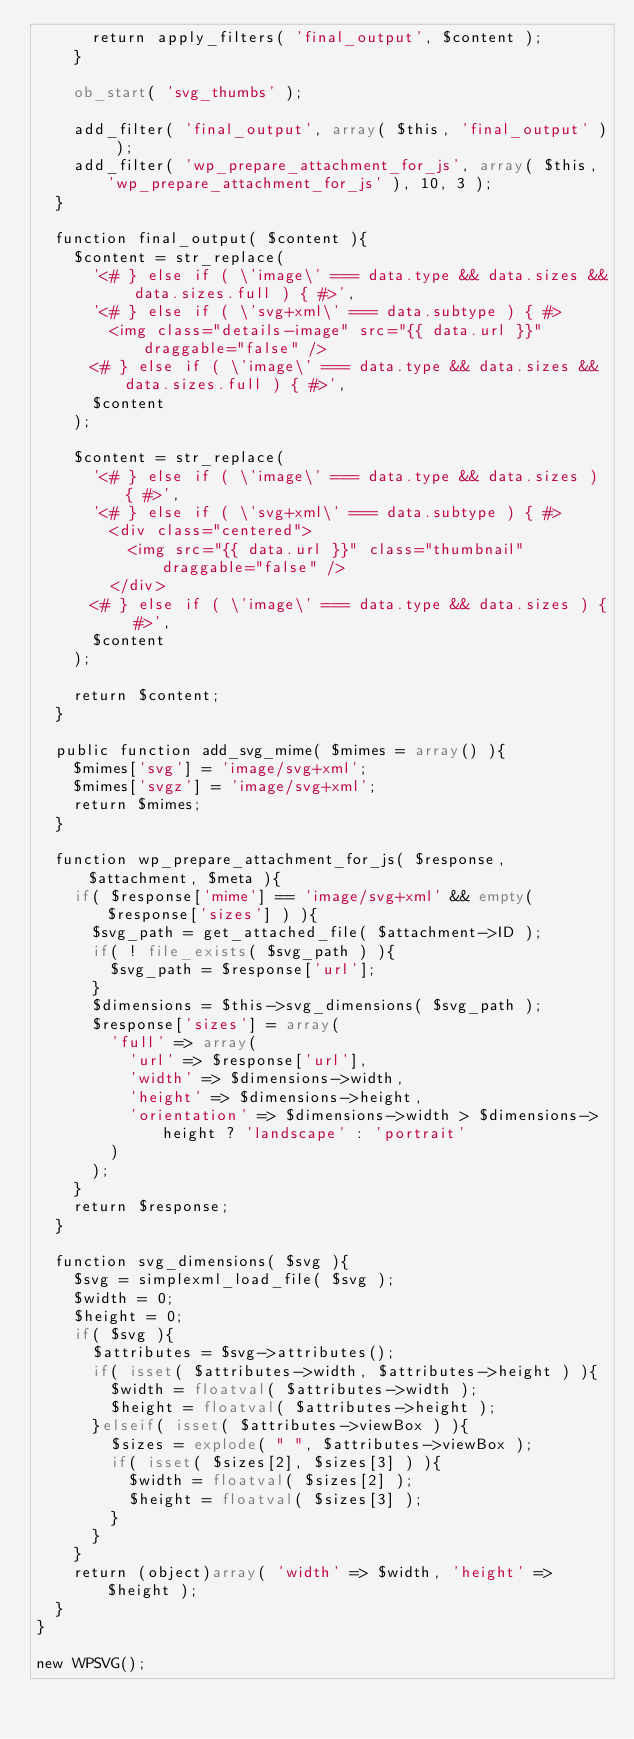<code> <loc_0><loc_0><loc_500><loc_500><_PHP_>			return apply_filters( 'final_output', $content );
		}

		ob_start( 'svg_thumbs' );

		add_filter( 'final_output', array( $this, 'final_output' ) );
		add_filter( 'wp_prepare_attachment_for_js', array( $this, 'wp_prepare_attachment_for_js' ), 10, 3 );
	}

	function final_output( $content ){
		$content = str_replace(
			'<# } else if ( \'image\' === data.type && data.sizes && data.sizes.full ) { #>',
			'<# } else if ( \'svg+xml\' === data.subtype ) { #>
				<img class="details-image" src="{{ data.url }}" draggable="false" />
			<# } else if ( \'image\' === data.type && data.sizes && data.sizes.full ) { #>',
			$content
		);

		$content = str_replace(
			'<# } else if ( \'image\' === data.type && data.sizes ) { #>',
			'<# } else if ( \'svg+xml\' === data.subtype ) { #>
				<div class="centered">
					<img src="{{ data.url }}" class="thumbnail" draggable="false" />
				</div>
			<# } else if ( \'image\' === data.type && data.sizes ) { #>',
			$content
		);

		return $content;
	}

	public function add_svg_mime( $mimes = array() ){
		$mimes['svg'] = 'image/svg+xml';
		$mimes['svgz'] = 'image/svg+xml';
		return $mimes;
	}

	function wp_prepare_attachment_for_js( $response, $attachment, $meta ){
		if( $response['mime'] == 'image/svg+xml' && empty( $response['sizes'] ) ){
			$svg_path = get_attached_file( $attachment->ID );
			if( ! file_exists( $svg_path ) ){
				$svg_path = $response['url'];
			}
			$dimensions = $this->svg_dimensions( $svg_path );
			$response['sizes'] = array(
				'full' => array(
					'url' => $response['url'],
					'width' => $dimensions->width,
					'height' => $dimensions->height,
					'orientation' => $dimensions->width > $dimensions->height ? 'landscape' : 'portrait'
				)
			);
		}
		return $response;
	}

	function svg_dimensions( $svg ){
		$svg = simplexml_load_file( $svg );
		$width = 0;
		$height = 0;
		if( $svg ){
			$attributes = $svg->attributes();
			if( isset( $attributes->width, $attributes->height ) ){
				$width = floatval( $attributes->width );
				$height = floatval( $attributes->height );
			}elseif( isset( $attributes->viewBox ) ){
				$sizes = explode( " ", $attributes->viewBox );
				if( isset( $sizes[2], $sizes[3] ) ){
					$width = floatval( $sizes[2] );
					$height = floatval( $sizes[3] );
				}
			}
		}
		return (object)array( 'width' => $width, 'height' => $height );
	}
}

new WPSVG();</code> 